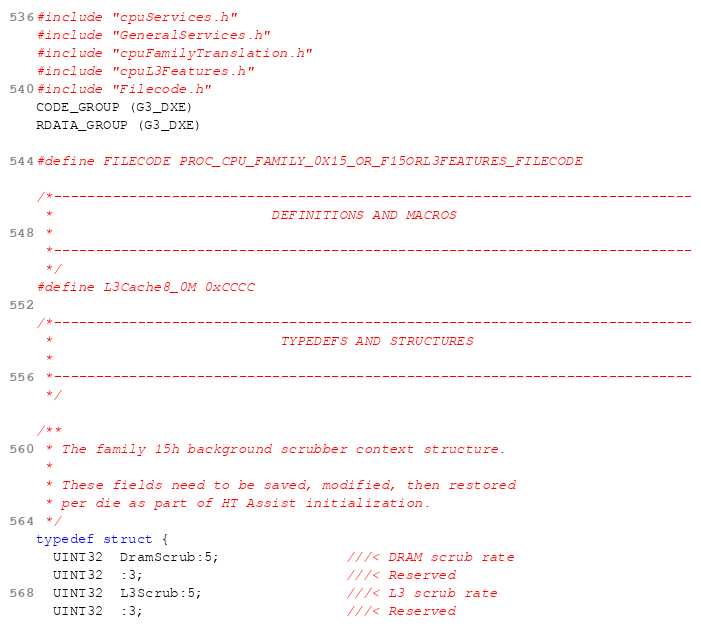Convert code to text. <code><loc_0><loc_0><loc_500><loc_500><_C_>#include "cpuServices.h"
#include "GeneralServices.h"
#include "cpuFamilyTranslation.h"
#include "cpuL3Features.h"
#include "Filecode.h"
CODE_GROUP (G3_DXE)
RDATA_GROUP (G3_DXE)

#define FILECODE PROC_CPU_FAMILY_0X15_OR_F15ORL3FEATURES_FILECODE

/*----------------------------------------------------------------------------
 *                          DEFINITIONS AND MACROS
 *
 *----------------------------------------------------------------------------
 */
#define L3Cache8_0M 0xCCCC

/*----------------------------------------------------------------------------
 *                           TYPEDEFS AND STRUCTURES
 *
 *----------------------------------------------------------------------------
 */

/**
 * The family 15h background scrubber context structure.
 *
 * These fields need to be saved, modified, then restored
 * per die as part of HT Assist initialization.
 */
typedef struct {
  UINT32  DramScrub:5;               ///< DRAM scrub rate
  UINT32  :3;                        ///< Reserved
  UINT32  L3Scrub:5;                 ///< L3 scrub rate
  UINT32  :3;                        ///< Reserved</code> 